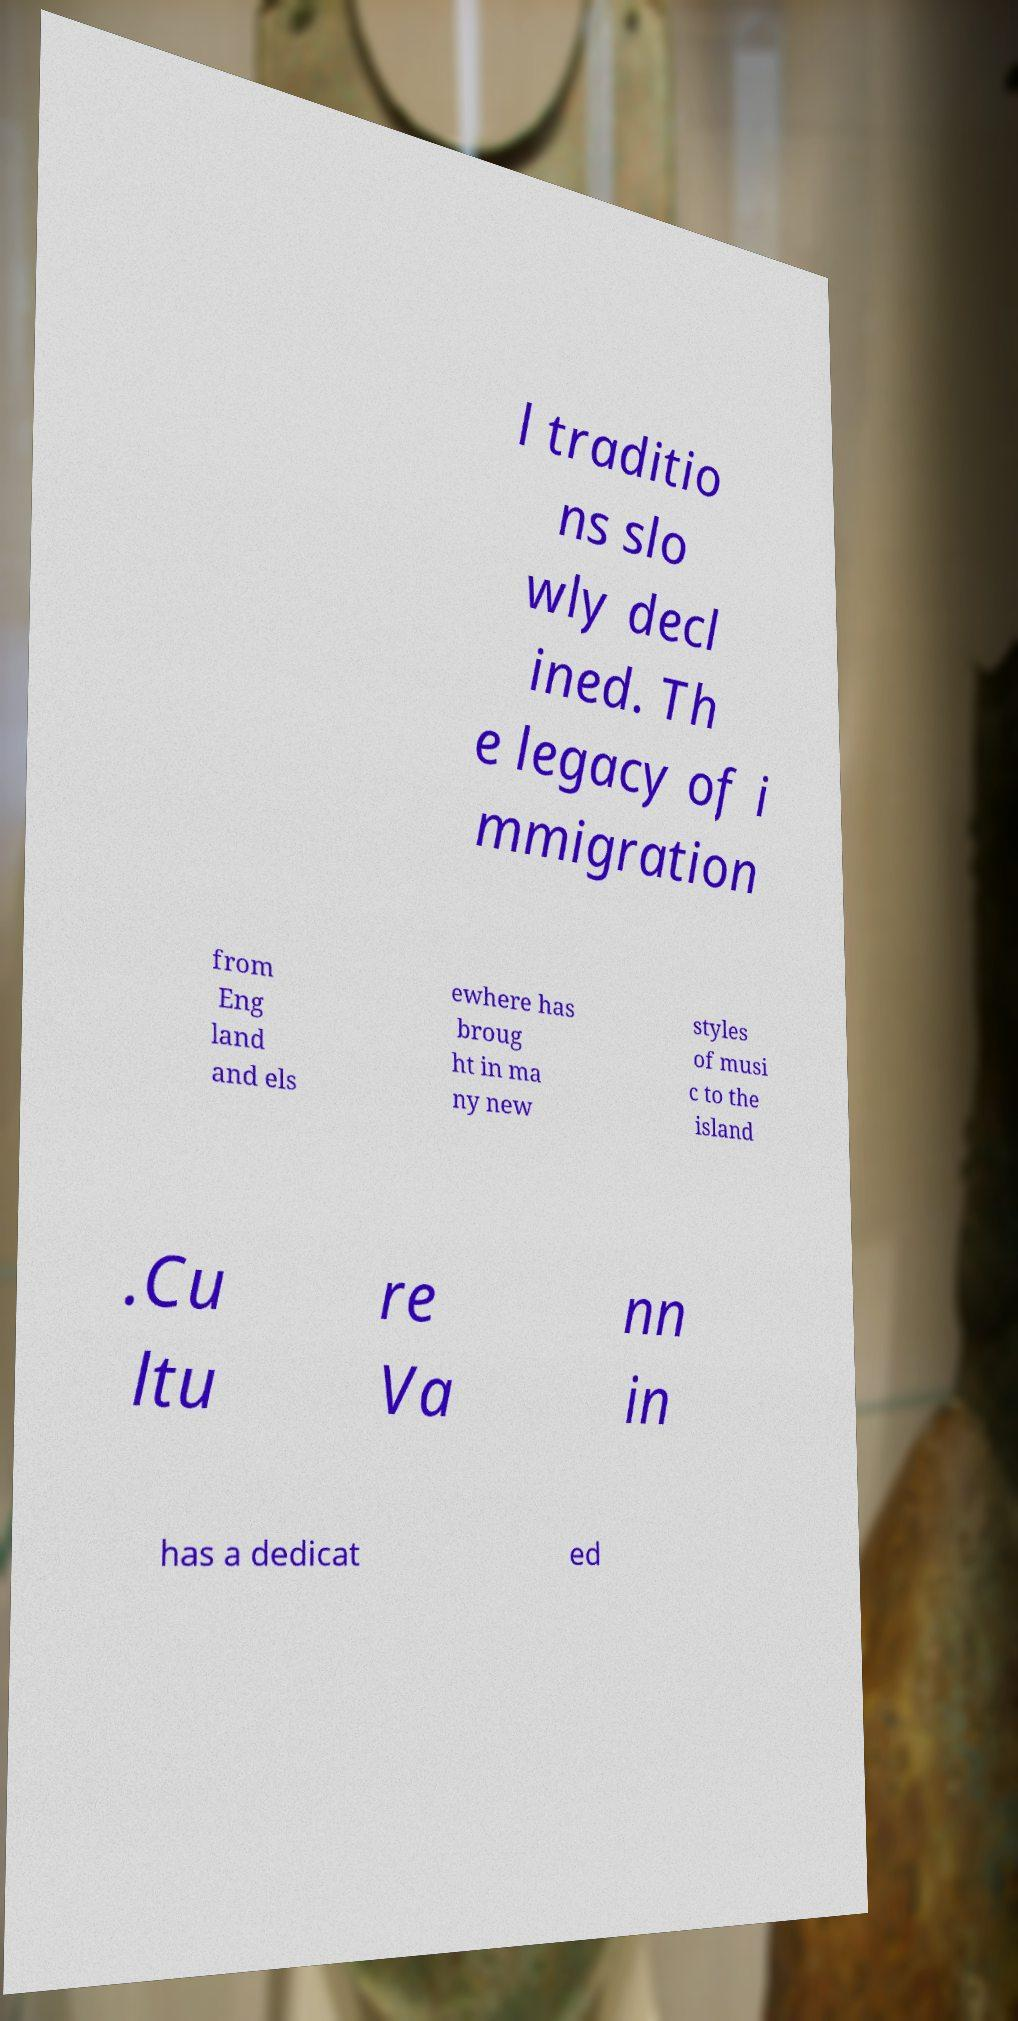Can you read and provide the text displayed in the image?This photo seems to have some interesting text. Can you extract and type it out for me? l traditio ns slo wly decl ined. Th e legacy of i mmigration from Eng land and els ewhere has broug ht in ma ny new styles of musi c to the island .Cu ltu re Va nn in has a dedicat ed 